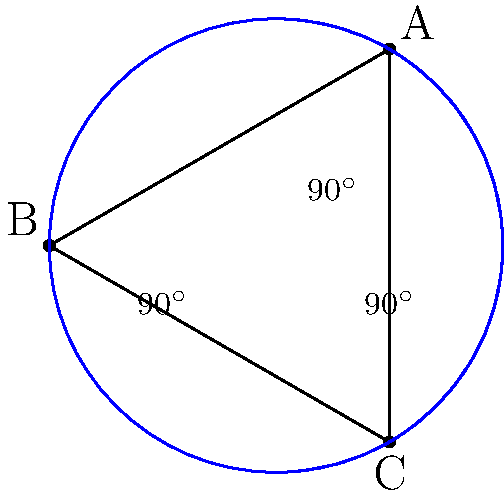Consider a triangle ABC on the surface of a sphere, where each side of the triangle is a great circle arc. If each angle of the triangle measures 90°, what is the sum of the interior angles of this triangle? Provide your answer in degrees. To solve this problem, we need to understand the principles of spherical geometry:

1. In spherical geometry, the sum of the interior angles of a triangle is always greater than 180°.

2. The excess of the sum over 180° is proportional to the area of the triangle on the sphere's surface.

3. In this case, we are given that each angle of the triangle is 90°.

4. To calculate the sum, we simply add the three angles:

   $90^\circ + 90^\circ + 90^\circ = 270^\circ$

5. This result confirms that in spherical geometry, the sum of the angles in a triangle can indeed exceed 180°.

6. The triangle described here is known as a "tri-rectangular" spherical triangle, which covers one-eighth of the sphere's surface.

7. This type of triangle is a fundamental concept in spherical geometry and has applications in navigation and astronomy.
Answer: $270^\circ$ 